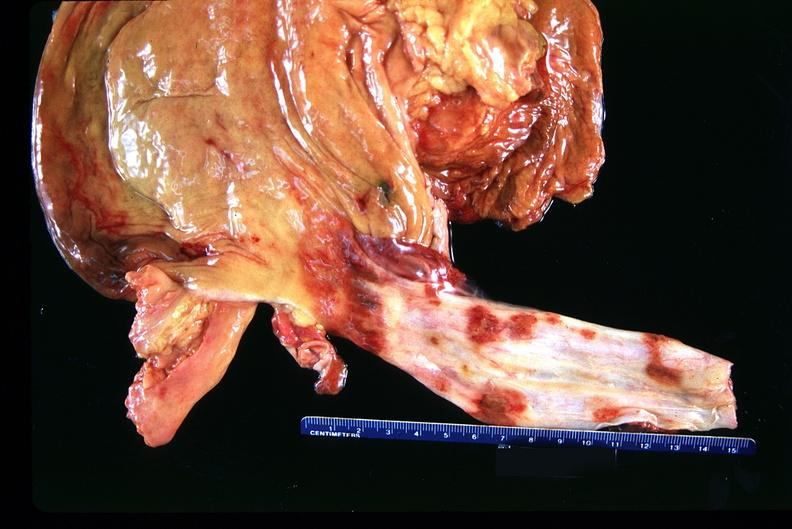does this image shows of smooth muscle cell with lipid in sarcoplasm and lipid show stomach and esophagus, ulcers?
Answer the question using a single word or phrase. No 